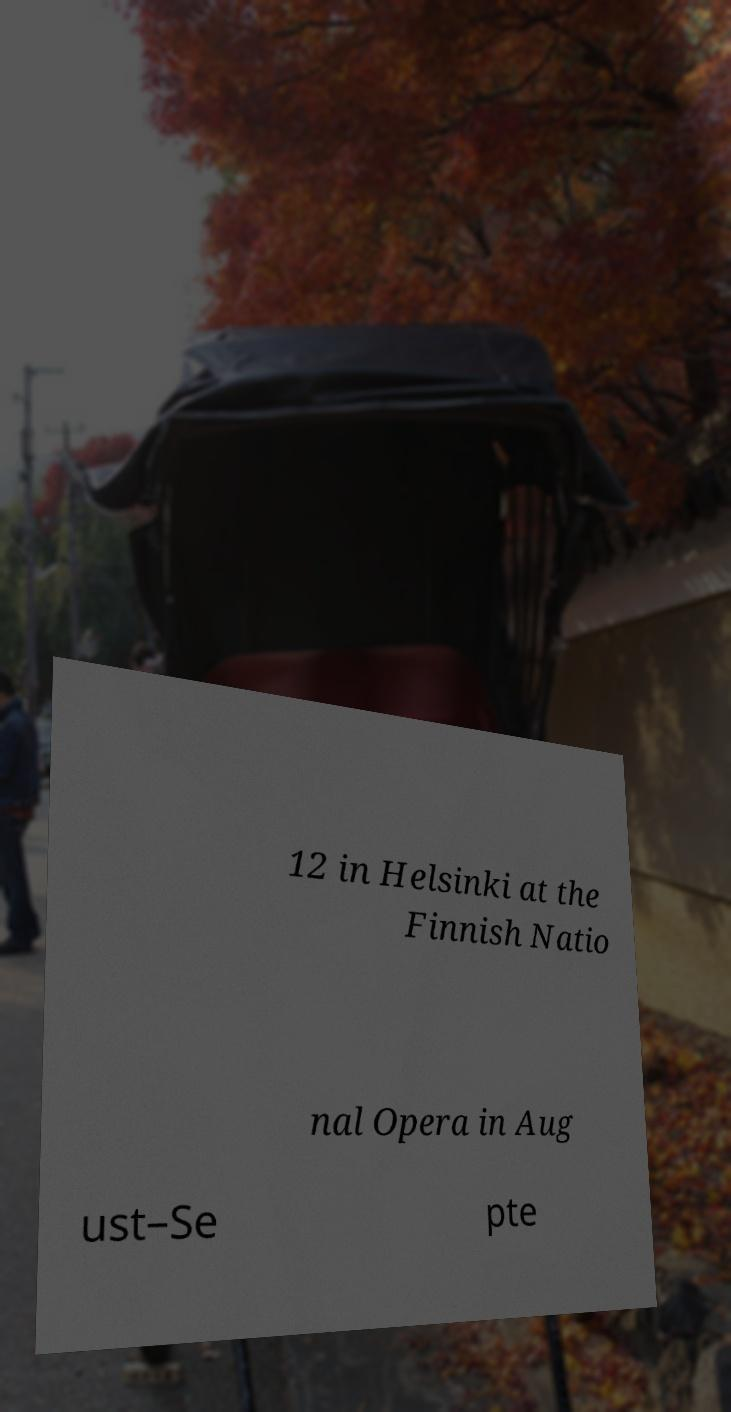Please read and relay the text visible in this image. What does it say? 12 in Helsinki at the Finnish Natio nal Opera in Aug ust–Se pte 